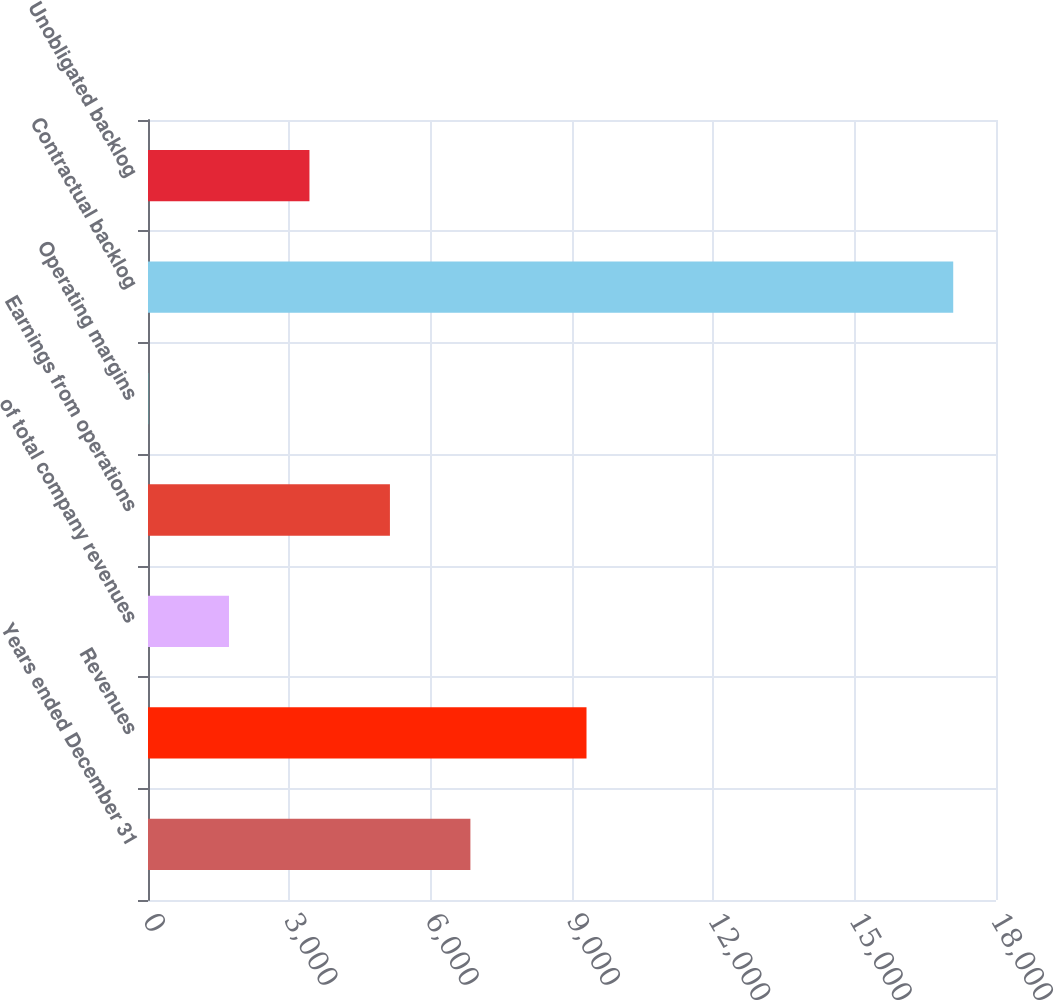<chart> <loc_0><loc_0><loc_500><loc_500><bar_chart><fcel>Years ended December 31<fcel>Revenues<fcel>of total company revenues<fcel>Earnings from operations<fcel>Operating margins<fcel>Contractual backlog<fcel>Unobligated backlog<nl><fcel>6843.34<fcel>9308<fcel>1719.01<fcel>5135.23<fcel>10.9<fcel>17092<fcel>3427.12<nl></chart> 